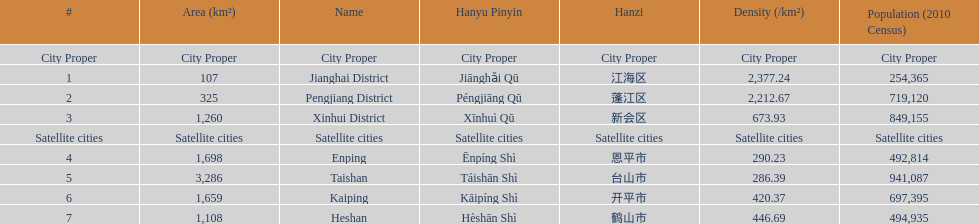Which area is the least dense? Taishan. 